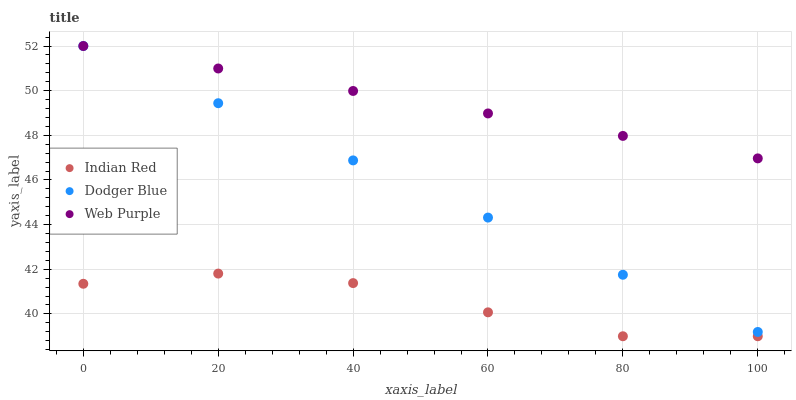Does Indian Red have the minimum area under the curve?
Answer yes or no. Yes. Does Web Purple have the maximum area under the curve?
Answer yes or no. Yes. Does Dodger Blue have the minimum area under the curve?
Answer yes or no. No. Does Dodger Blue have the maximum area under the curve?
Answer yes or no. No. Is Dodger Blue the smoothest?
Answer yes or no. Yes. Is Indian Red the roughest?
Answer yes or no. Yes. Is Indian Red the smoothest?
Answer yes or no. No. Is Dodger Blue the roughest?
Answer yes or no. No. Does Indian Red have the lowest value?
Answer yes or no. Yes. Does Dodger Blue have the lowest value?
Answer yes or no. No. Does Dodger Blue have the highest value?
Answer yes or no. Yes. Does Indian Red have the highest value?
Answer yes or no. No. Is Indian Red less than Web Purple?
Answer yes or no. Yes. Is Web Purple greater than Indian Red?
Answer yes or no. Yes. Does Web Purple intersect Dodger Blue?
Answer yes or no. Yes. Is Web Purple less than Dodger Blue?
Answer yes or no. No. Is Web Purple greater than Dodger Blue?
Answer yes or no. No. Does Indian Red intersect Web Purple?
Answer yes or no. No. 